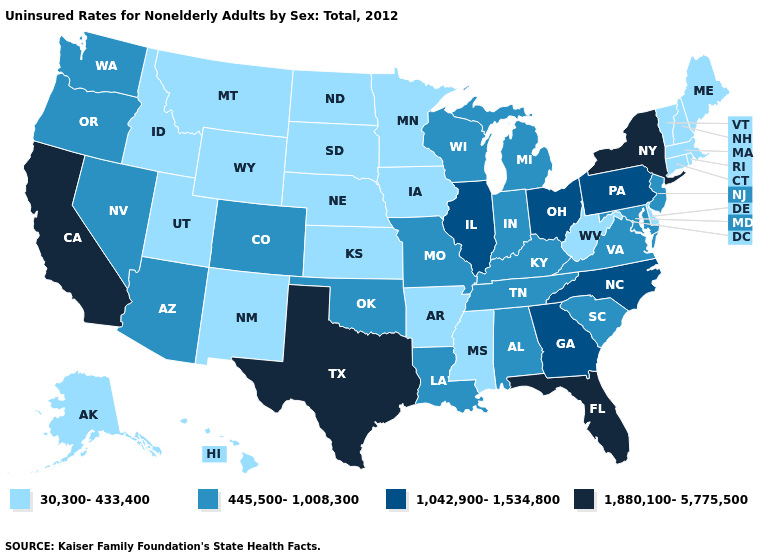Which states have the highest value in the USA?
Answer briefly. California, Florida, New York, Texas. What is the highest value in the USA?
Answer briefly. 1,880,100-5,775,500. How many symbols are there in the legend?
Concise answer only. 4. Which states have the lowest value in the USA?
Quick response, please. Alaska, Arkansas, Connecticut, Delaware, Hawaii, Idaho, Iowa, Kansas, Maine, Massachusetts, Minnesota, Mississippi, Montana, Nebraska, New Hampshire, New Mexico, North Dakota, Rhode Island, South Dakota, Utah, Vermont, West Virginia, Wyoming. Which states have the lowest value in the USA?
Short answer required. Alaska, Arkansas, Connecticut, Delaware, Hawaii, Idaho, Iowa, Kansas, Maine, Massachusetts, Minnesota, Mississippi, Montana, Nebraska, New Hampshire, New Mexico, North Dakota, Rhode Island, South Dakota, Utah, Vermont, West Virginia, Wyoming. Is the legend a continuous bar?
Short answer required. No. Does the first symbol in the legend represent the smallest category?
Keep it brief. Yes. Does Vermont have the lowest value in the Northeast?
Give a very brief answer. Yes. What is the value of Utah?
Keep it brief. 30,300-433,400. Name the states that have a value in the range 1,042,900-1,534,800?
Be succinct. Georgia, Illinois, North Carolina, Ohio, Pennsylvania. How many symbols are there in the legend?
Keep it brief. 4. Name the states that have a value in the range 1,880,100-5,775,500?
Keep it brief. California, Florida, New York, Texas. Name the states that have a value in the range 1,880,100-5,775,500?
Write a very short answer. California, Florida, New York, Texas. What is the value of Illinois?
Concise answer only. 1,042,900-1,534,800. What is the lowest value in the USA?
Write a very short answer. 30,300-433,400. 